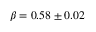<formula> <loc_0><loc_0><loc_500><loc_500>\beta = 0 . 5 8 \pm 0 . 0 2</formula> 